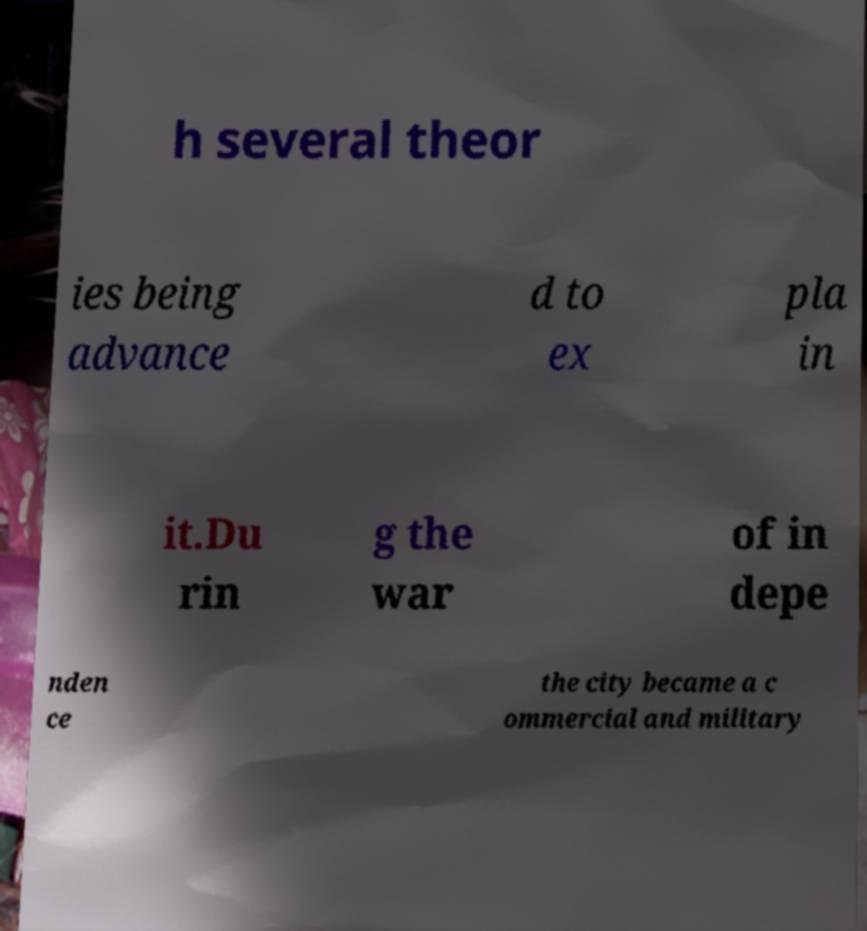Can you read and provide the text displayed in the image?This photo seems to have some interesting text. Can you extract and type it out for me? h several theor ies being advance d to ex pla in it.Du rin g the war of in depe nden ce the city became a c ommercial and military 